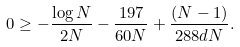<formula> <loc_0><loc_0><loc_500><loc_500>0 \geq - \frac { \log N } { 2 N } - \frac { 1 9 7 } { 6 0 N } + \frac { ( N - 1 ) } { 2 8 8 d N } .</formula> 